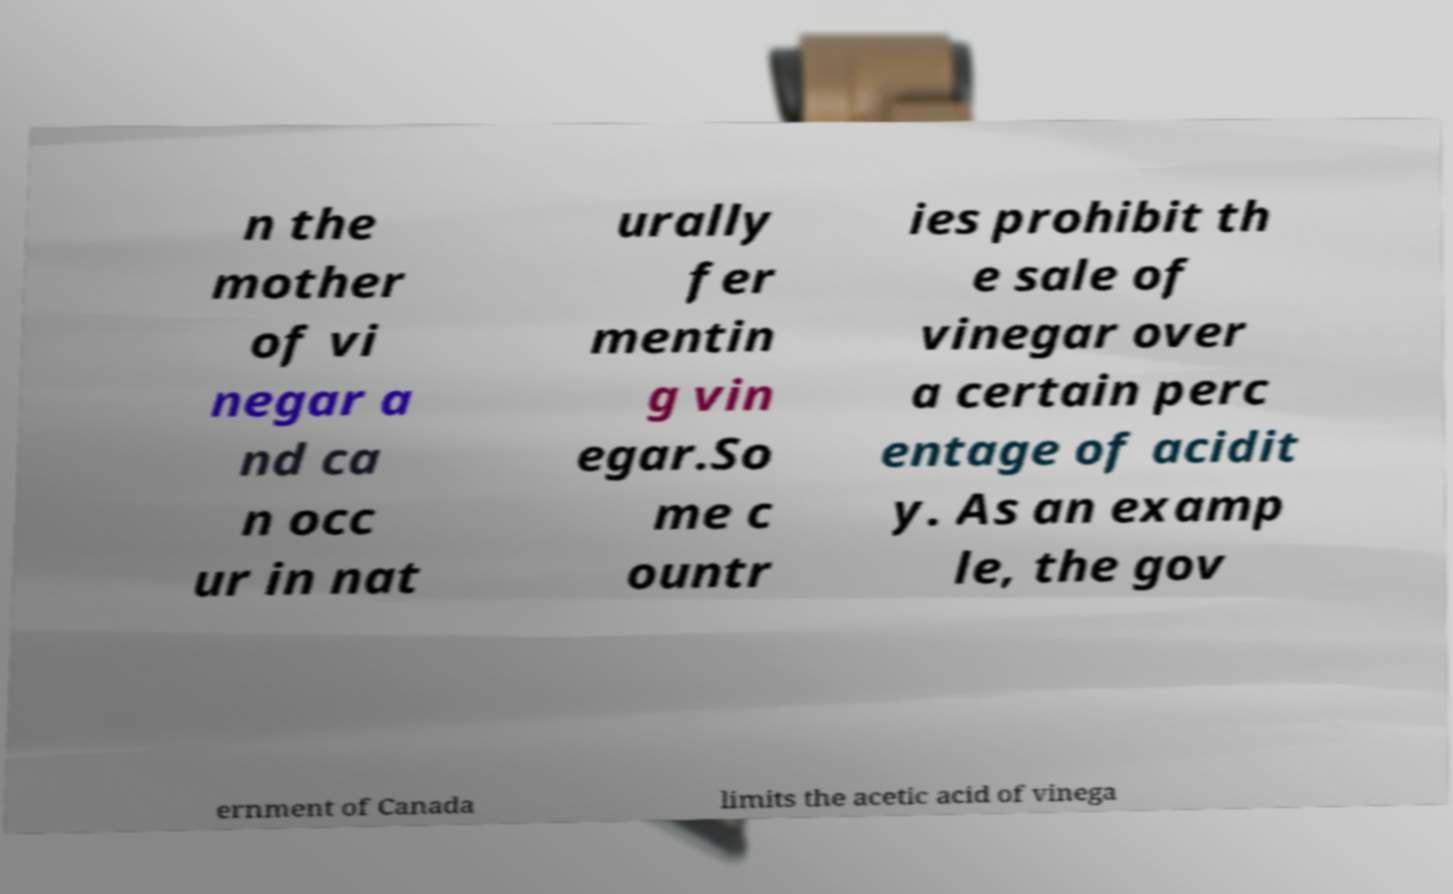I need the written content from this picture converted into text. Can you do that? n the mother of vi negar a nd ca n occ ur in nat urally fer mentin g vin egar.So me c ountr ies prohibit th e sale of vinegar over a certain perc entage of acidit y. As an examp le, the gov ernment of Canada limits the acetic acid of vinega 